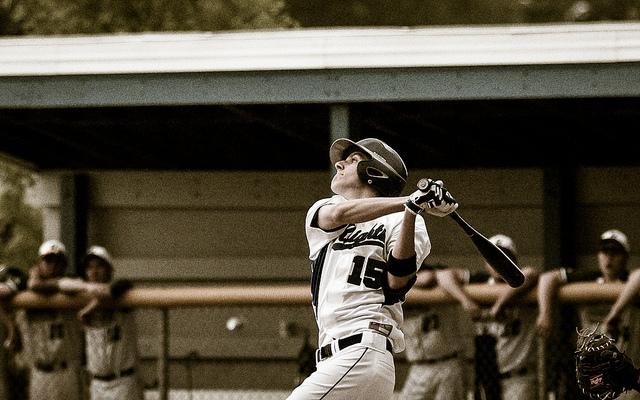What number is on the player's shirt?
Quick response, please. 15. On what arm is the player in the foreground wearing an armband?
Quick response, please. Left. What is the player looking at?
Concise answer only. Ball. 